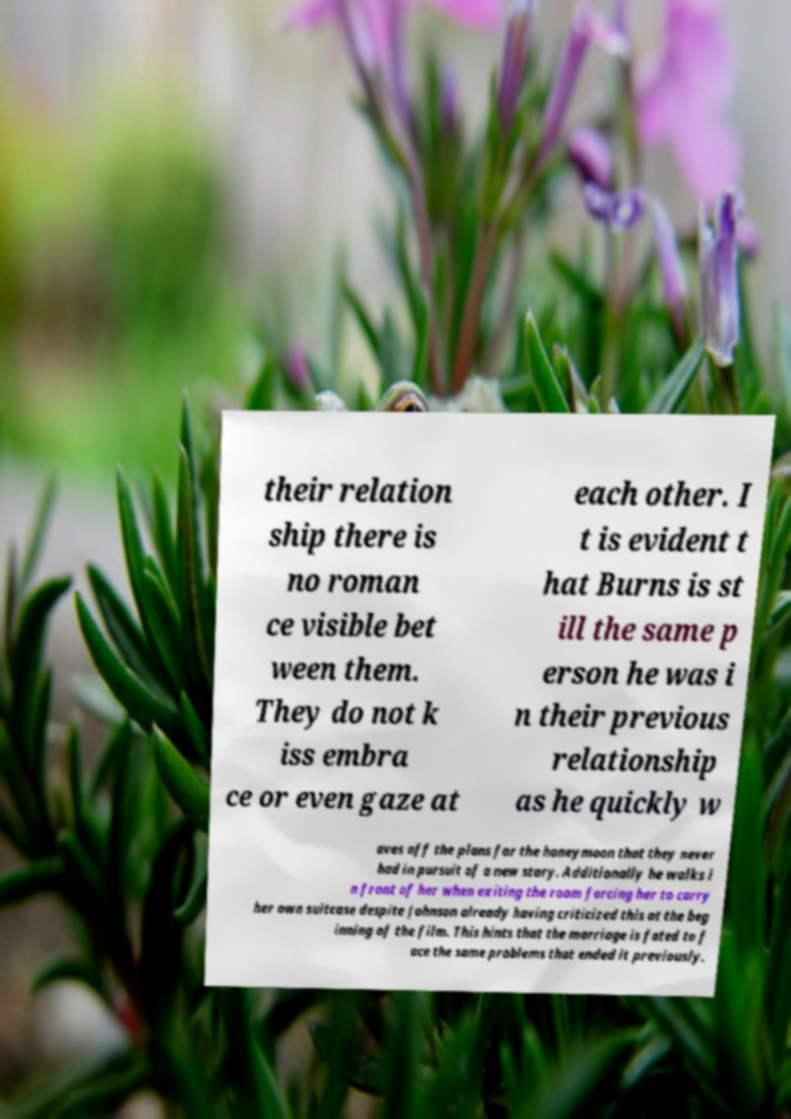For documentation purposes, I need the text within this image transcribed. Could you provide that? their relation ship there is no roman ce visible bet ween them. They do not k iss embra ce or even gaze at each other. I t is evident t hat Burns is st ill the same p erson he was i n their previous relationship as he quickly w aves off the plans for the honeymoon that they never had in pursuit of a new story. Additionally he walks i n front of her when exiting the room forcing her to carry her own suitcase despite Johnson already having criticized this at the beg inning of the film. This hints that the marriage is fated to f ace the same problems that ended it previously. 